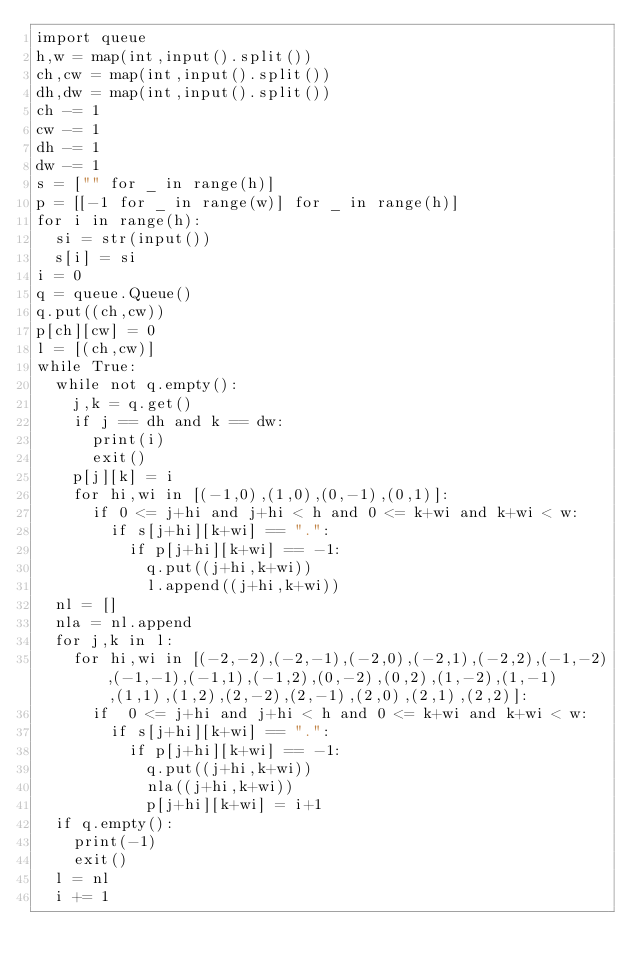<code> <loc_0><loc_0><loc_500><loc_500><_Python_>import queue
h,w = map(int,input().split())
ch,cw = map(int,input().split())
dh,dw = map(int,input().split())
ch -= 1
cw -= 1
dh -= 1
dw -= 1
s = ["" for _ in range(h)]
p = [[-1 for _ in range(w)] for _ in range(h)]
for i in range(h):
  si = str(input())
  s[i] = si  
i = 0
q = queue.Queue()
q.put((ch,cw))
p[ch][cw] = 0
l = [(ch,cw)]
while True:
  while not q.empty():
    j,k = q.get()
    if j == dh and k == dw:
      print(i)
      exit()
    p[j][k] = i
    for hi,wi in [(-1,0),(1,0),(0,-1),(0,1)]:
      if 0 <= j+hi and j+hi < h and 0 <= k+wi and k+wi < w:
        if s[j+hi][k+wi] == ".":
          if p[j+hi][k+wi] == -1:
            q.put((j+hi,k+wi))
            l.append((j+hi,k+wi))
  nl = []
  nla = nl.append
  for j,k in l:
    for hi,wi in [(-2,-2),(-2,-1),(-2,0),(-2,1),(-2,2),(-1,-2),(-1,-1),(-1,1),(-1,2),(0,-2),(0,2),(1,-2),(1,-1),(1,1),(1,2),(2,-2),(2,-1),(2,0),(2,1),(2,2)]:
      if  0 <= j+hi and j+hi < h and 0 <= k+wi and k+wi < w:
        if s[j+hi][k+wi] == ".":
          if p[j+hi][k+wi] == -1:
            q.put((j+hi,k+wi))
            nla((j+hi,k+wi))
            p[j+hi][k+wi] = i+1
  if q.empty():
    print(-1)
    exit()
  l = nl
  i += 1</code> 